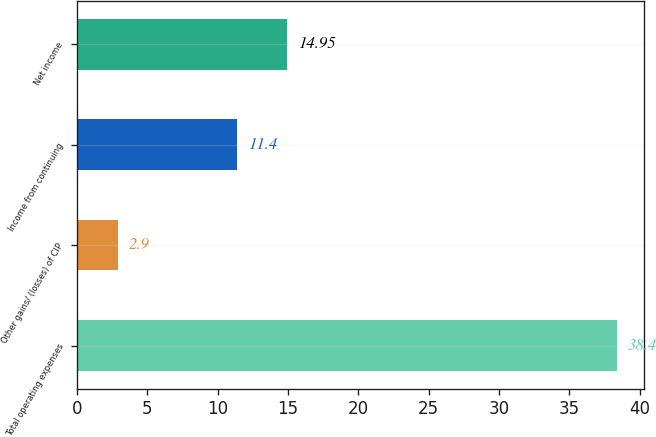<chart> <loc_0><loc_0><loc_500><loc_500><bar_chart><fcel>Total operating expenses<fcel>Other gains/ (losses) of CIP<fcel>Income from continuing<fcel>Net income<nl><fcel>38.4<fcel>2.9<fcel>11.4<fcel>14.95<nl></chart> 